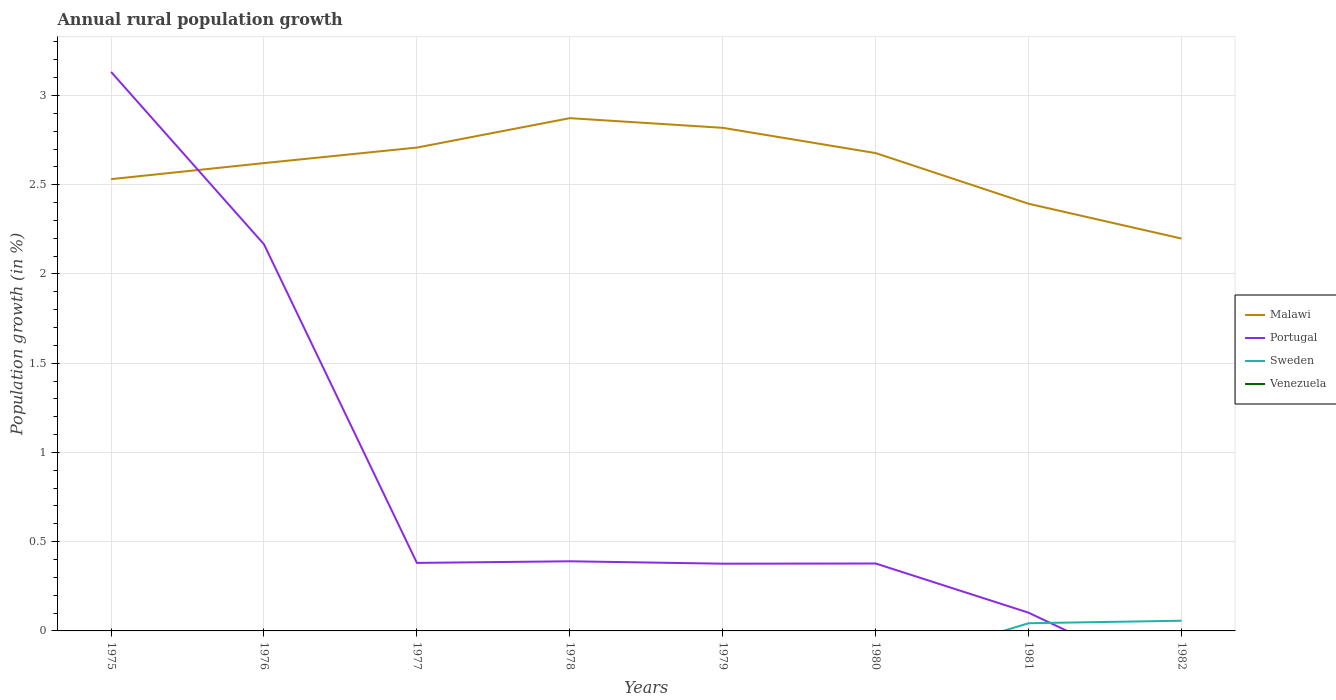Is the number of lines equal to the number of legend labels?
Your answer should be compact. No. Across all years, what is the maximum percentage of rural population growth in Malawi?
Provide a short and direct response. 2.2. What is the total percentage of rural population growth in Malawi in the graph?
Offer a very short reply. 0.42. What is the difference between the highest and the second highest percentage of rural population growth in Portugal?
Your answer should be very brief. 3.13. What is the difference between the highest and the lowest percentage of rural population growth in Malawi?
Make the answer very short. 5. What is the difference between two consecutive major ticks on the Y-axis?
Your answer should be very brief. 0.5. Does the graph contain any zero values?
Offer a terse response. Yes. Does the graph contain grids?
Keep it short and to the point. Yes. Where does the legend appear in the graph?
Provide a succinct answer. Center right. How many legend labels are there?
Your answer should be very brief. 4. How are the legend labels stacked?
Your answer should be very brief. Vertical. What is the title of the graph?
Ensure brevity in your answer.  Annual rural population growth. Does "Uzbekistan" appear as one of the legend labels in the graph?
Make the answer very short. No. What is the label or title of the X-axis?
Keep it short and to the point. Years. What is the label or title of the Y-axis?
Ensure brevity in your answer.  Population growth (in %). What is the Population growth (in %) of Malawi in 1975?
Your response must be concise. 2.53. What is the Population growth (in %) in Portugal in 1975?
Give a very brief answer. 3.13. What is the Population growth (in %) of Sweden in 1975?
Make the answer very short. 0. What is the Population growth (in %) in Venezuela in 1975?
Provide a short and direct response. 0. What is the Population growth (in %) of Malawi in 1976?
Your answer should be very brief. 2.62. What is the Population growth (in %) of Portugal in 1976?
Your response must be concise. 2.17. What is the Population growth (in %) in Malawi in 1977?
Ensure brevity in your answer.  2.71. What is the Population growth (in %) of Portugal in 1977?
Offer a very short reply. 0.38. What is the Population growth (in %) in Venezuela in 1977?
Offer a terse response. 0. What is the Population growth (in %) of Malawi in 1978?
Offer a very short reply. 2.87. What is the Population growth (in %) of Portugal in 1978?
Provide a short and direct response. 0.39. What is the Population growth (in %) of Sweden in 1978?
Offer a terse response. 0. What is the Population growth (in %) in Malawi in 1979?
Ensure brevity in your answer.  2.82. What is the Population growth (in %) in Portugal in 1979?
Give a very brief answer. 0.38. What is the Population growth (in %) in Venezuela in 1979?
Your response must be concise. 0. What is the Population growth (in %) of Malawi in 1980?
Keep it short and to the point. 2.68. What is the Population growth (in %) in Portugal in 1980?
Your answer should be very brief. 0.38. What is the Population growth (in %) of Sweden in 1980?
Give a very brief answer. 0. What is the Population growth (in %) in Malawi in 1981?
Your answer should be very brief. 2.39. What is the Population growth (in %) in Portugal in 1981?
Keep it short and to the point. 0.1. What is the Population growth (in %) of Sweden in 1981?
Your answer should be compact. 0.04. What is the Population growth (in %) of Malawi in 1982?
Give a very brief answer. 2.2. What is the Population growth (in %) in Sweden in 1982?
Make the answer very short. 0.06. What is the Population growth (in %) in Venezuela in 1982?
Make the answer very short. 0. Across all years, what is the maximum Population growth (in %) in Malawi?
Offer a terse response. 2.87. Across all years, what is the maximum Population growth (in %) of Portugal?
Make the answer very short. 3.13. Across all years, what is the maximum Population growth (in %) of Sweden?
Give a very brief answer. 0.06. Across all years, what is the minimum Population growth (in %) of Malawi?
Keep it short and to the point. 2.2. Across all years, what is the minimum Population growth (in %) of Sweden?
Provide a succinct answer. 0. What is the total Population growth (in %) in Malawi in the graph?
Your answer should be compact. 20.82. What is the total Population growth (in %) of Portugal in the graph?
Your response must be concise. 6.93. What is the total Population growth (in %) of Sweden in the graph?
Offer a terse response. 0.1. What is the total Population growth (in %) of Venezuela in the graph?
Provide a short and direct response. 0. What is the difference between the Population growth (in %) in Malawi in 1975 and that in 1976?
Offer a terse response. -0.09. What is the difference between the Population growth (in %) in Portugal in 1975 and that in 1976?
Your answer should be very brief. 0.97. What is the difference between the Population growth (in %) of Malawi in 1975 and that in 1977?
Give a very brief answer. -0.18. What is the difference between the Population growth (in %) in Portugal in 1975 and that in 1977?
Give a very brief answer. 2.75. What is the difference between the Population growth (in %) in Malawi in 1975 and that in 1978?
Your response must be concise. -0.34. What is the difference between the Population growth (in %) of Portugal in 1975 and that in 1978?
Offer a terse response. 2.74. What is the difference between the Population growth (in %) of Malawi in 1975 and that in 1979?
Your answer should be compact. -0.29. What is the difference between the Population growth (in %) of Portugal in 1975 and that in 1979?
Keep it short and to the point. 2.76. What is the difference between the Population growth (in %) in Malawi in 1975 and that in 1980?
Provide a short and direct response. -0.15. What is the difference between the Population growth (in %) of Portugal in 1975 and that in 1980?
Offer a terse response. 2.75. What is the difference between the Population growth (in %) of Malawi in 1975 and that in 1981?
Give a very brief answer. 0.14. What is the difference between the Population growth (in %) of Portugal in 1975 and that in 1981?
Offer a very short reply. 3.03. What is the difference between the Population growth (in %) in Malawi in 1975 and that in 1982?
Give a very brief answer. 0.33. What is the difference between the Population growth (in %) in Malawi in 1976 and that in 1977?
Your answer should be compact. -0.09. What is the difference between the Population growth (in %) of Portugal in 1976 and that in 1977?
Offer a terse response. 1.79. What is the difference between the Population growth (in %) in Malawi in 1976 and that in 1978?
Give a very brief answer. -0.25. What is the difference between the Population growth (in %) in Portugal in 1976 and that in 1978?
Give a very brief answer. 1.78. What is the difference between the Population growth (in %) in Malawi in 1976 and that in 1979?
Provide a succinct answer. -0.2. What is the difference between the Population growth (in %) in Portugal in 1976 and that in 1979?
Your response must be concise. 1.79. What is the difference between the Population growth (in %) in Malawi in 1976 and that in 1980?
Give a very brief answer. -0.06. What is the difference between the Population growth (in %) in Portugal in 1976 and that in 1980?
Make the answer very short. 1.79. What is the difference between the Population growth (in %) of Malawi in 1976 and that in 1981?
Keep it short and to the point. 0.23. What is the difference between the Population growth (in %) in Portugal in 1976 and that in 1981?
Your answer should be very brief. 2.06. What is the difference between the Population growth (in %) in Malawi in 1976 and that in 1982?
Keep it short and to the point. 0.42. What is the difference between the Population growth (in %) in Malawi in 1977 and that in 1978?
Make the answer very short. -0.16. What is the difference between the Population growth (in %) in Portugal in 1977 and that in 1978?
Your answer should be compact. -0.01. What is the difference between the Population growth (in %) of Malawi in 1977 and that in 1979?
Offer a terse response. -0.11. What is the difference between the Population growth (in %) of Portugal in 1977 and that in 1979?
Give a very brief answer. 0. What is the difference between the Population growth (in %) of Malawi in 1977 and that in 1980?
Ensure brevity in your answer.  0.03. What is the difference between the Population growth (in %) in Portugal in 1977 and that in 1980?
Your response must be concise. 0. What is the difference between the Population growth (in %) in Malawi in 1977 and that in 1981?
Offer a terse response. 0.31. What is the difference between the Population growth (in %) in Portugal in 1977 and that in 1981?
Your answer should be very brief. 0.28. What is the difference between the Population growth (in %) of Malawi in 1977 and that in 1982?
Your response must be concise. 0.51. What is the difference between the Population growth (in %) in Malawi in 1978 and that in 1979?
Your answer should be very brief. 0.05. What is the difference between the Population growth (in %) of Portugal in 1978 and that in 1979?
Provide a short and direct response. 0.01. What is the difference between the Population growth (in %) of Malawi in 1978 and that in 1980?
Keep it short and to the point. 0.2. What is the difference between the Population growth (in %) of Portugal in 1978 and that in 1980?
Provide a short and direct response. 0.01. What is the difference between the Population growth (in %) of Malawi in 1978 and that in 1981?
Give a very brief answer. 0.48. What is the difference between the Population growth (in %) of Portugal in 1978 and that in 1981?
Your answer should be very brief. 0.29. What is the difference between the Population growth (in %) in Malawi in 1978 and that in 1982?
Provide a short and direct response. 0.67. What is the difference between the Population growth (in %) of Malawi in 1979 and that in 1980?
Give a very brief answer. 0.14. What is the difference between the Population growth (in %) of Portugal in 1979 and that in 1980?
Make the answer very short. -0. What is the difference between the Population growth (in %) of Malawi in 1979 and that in 1981?
Ensure brevity in your answer.  0.43. What is the difference between the Population growth (in %) of Portugal in 1979 and that in 1981?
Provide a short and direct response. 0.27. What is the difference between the Population growth (in %) in Malawi in 1979 and that in 1982?
Ensure brevity in your answer.  0.62. What is the difference between the Population growth (in %) in Malawi in 1980 and that in 1981?
Your answer should be compact. 0.28. What is the difference between the Population growth (in %) of Portugal in 1980 and that in 1981?
Your answer should be compact. 0.28. What is the difference between the Population growth (in %) of Malawi in 1980 and that in 1982?
Make the answer very short. 0.48. What is the difference between the Population growth (in %) of Malawi in 1981 and that in 1982?
Ensure brevity in your answer.  0.2. What is the difference between the Population growth (in %) in Sweden in 1981 and that in 1982?
Provide a succinct answer. -0.01. What is the difference between the Population growth (in %) in Malawi in 1975 and the Population growth (in %) in Portugal in 1976?
Offer a very short reply. 0.37. What is the difference between the Population growth (in %) in Malawi in 1975 and the Population growth (in %) in Portugal in 1977?
Keep it short and to the point. 2.15. What is the difference between the Population growth (in %) of Malawi in 1975 and the Population growth (in %) of Portugal in 1978?
Make the answer very short. 2.14. What is the difference between the Population growth (in %) of Malawi in 1975 and the Population growth (in %) of Portugal in 1979?
Make the answer very short. 2.15. What is the difference between the Population growth (in %) in Malawi in 1975 and the Population growth (in %) in Portugal in 1980?
Make the answer very short. 2.15. What is the difference between the Population growth (in %) of Malawi in 1975 and the Population growth (in %) of Portugal in 1981?
Provide a short and direct response. 2.43. What is the difference between the Population growth (in %) of Malawi in 1975 and the Population growth (in %) of Sweden in 1981?
Make the answer very short. 2.49. What is the difference between the Population growth (in %) in Portugal in 1975 and the Population growth (in %) in Sweden in 1981?
Keep it short and to the point. 3.09. What is the difference between the Population growth (in %) in Malawi in 1975 and the Population growth (in %) in Sweden in 1982?
Provide a succinct answer. 2.47. What is the difference between the Population growth (in %) in Portugal in 1975 and the Population growth (in %) in Sweden in 1982?
Your response must be concise. 3.08. What is the difference between the Population growth (in %) of Malawi in 1976 and the Population growth (in %) of Portugal in 1977?
Offer a terse response. 2.24. What is the difference between the Population growth (in %) in Malawi in 1976 and the Population growth (in %) in Portugal in 1978?
Give a very brief answer. 2.23. What is the difference between the Population growth (in %) in Malawi in 1976 and the Population growth (in %) in Portugal in 1979?
Provide a succinct answer. 2.24. What is the difference between the Population growth (in %) of Malawi in 1976 and the Population growth (in %) of Portugal in 1980?
Provide a short and direct response. 2.24. What is the difference between the Population growth (in %) in Malawi in 1976 and the Population growth (in %) in Portugal in 1981?
Provide a short and direct response. 2.52. What is the difference between the Population growth (in %) in Malawi in 1976 and the Population growth (in %) in Sweden in 1981?
Make the answer very short. 2.58. What is the difference between the Population growth (in %) of Portugal in 1976 and the Population growth (in %) of Sweden in 1981?
Make the answer very short. 2.12. What is the difference between the Population growth (in %) in Malawi in 1976 and the Population growth (in %) in Sweden in 1982?
Provide a succinct answer. 2.56. What is the difference between the Population growth (in %) in Portugal in 1976 and the Population growth (in %) in Sweden in 1982?
Offer a terse response. 2.11. What is the difference between the Population growth (in %) of Malawi in 1977 and the Population growth (in %) of Portugal in 1978?
Offer a very short reply. 2.32. What is the difference between the Population growth (in %) in Malawi in 1977 and the Population growth (in %) in Portugal in 1979?
Ensure brevity in your answer.  2.33. What is the difference between the Population growth (in %) of Malawi in 1977 and the Population growth (in %) of Portugal in 1980?
Your answer should be very brief. 2.33. What is the difference between the Population growth (in %) in Malawi in 1977 and the Population growth (in %) in Portugal in 1981?
Offer a terse response. 2.61. What is the difference between the Population growth (in %) of Malawi in 1977 and the Population growth (in %) of Sweden in 1981?
Make the answer very short. 2.67. What is the difference between the Population growth (in %) of Portugal in 1977 and the Population growth (in %) of Sweden in 1981?
Make the answer very short. 0.34. What is the difference between the Population growth (in %) in Malawi in 1977 and the Population growth (in %) in Sweden in 1982?
Provide a succinct answer. 2.65. What is the difference between the Population growth (in %) in Portugal in 1977 and the Population growth (in %) in Sweden in 1982?
Keep it short and to the point. 0.32. What is the difference between the Population growth (in %) in Malawi in 1978 and the Population growth (in %) in Portugal in 1979?
Keep it short and to the point. 2.5. What is the difference between the Population growth (in %) in Malawi in 1978 and the Population growth (in %) in Portugal in 1980?
Provide a short and direct response. 2.5. What is the difference between the Population growth (in %) in Malawi in 1978 and the Population growth (in %) in Portugal in 1981?
Your answer should be very brief. 2.77. What is the difference between the Population growth (in %) of Malawi in 1978 and the Population growth (in %) of Sweden in 1981?
Offer a terse response. 2.83. What is the difference between the Population growth (in %) in Portugal in 1978 and the Population growth (in %) in Sweden in 1981?
Provide a succinct answer. 0.35. What is the difference between the Population growth (in %) in Malawi in 1978 and the Population growth (in %) in Sweden in 1982?
Your response must be concise. 2.82. What is the difference between the Population growth (in %) in Portugal in 1978 and the Population growth (in %) in Sweden in 1982?
Make the answer very short. 0.33. What is the difference between the Population growth (in %) of Malawi in 1979 and the Population growth (in %) of Portugal in 1980?
Offer a very short reply. 2.44. What is the difference between the Population growth (in %) in Malawi in 1979 and the Population growth (in %) in Portugal in 1981?
Offer a terse response. 2.72. What is the difference between the Population growth (in %) of Malawi in 1979 and the Population growth (in %) of Sweden in 1981?
Provide a short and direct response. 2.78. What is the difference between the Population growth (in %) in Portugal in 1979 and the Population growth (in %) in Sweden in 1981?
Give a very brief answer. 0.33. What is the difference between the Population growth (in %) of Malawi in 1979 and the Population growth (in %) of Sweden in 1982?
Your answer should be compact. 2.76. What is the difference between the Population growth (in %) of Portugal in 1979 and the Population growth (in %) of Sweden in 1982?
Ensure brevity in your answer.  0.32. What is the difference between the Population growth (in %) in Malawi in 1980 and the Population growth (in %) in Portugal in 1981?
Make the answer very short. 2.58. What is the difference between the Population growth (in %) in Malawi in 1980 and the Population growth (in %) in Sweden in 1981?
Your answer should be very brief. 2.63. What is the difference between the Population growth (in %) of Portugal in 1980 and the Population growth (in %) of Sweden in 1981?
Make the answer very short. 0.33. What is the difference between the Population growth (in %) of Malawi in 1980 and the Population growth (in %) of Sweden in 1982?
Ensure brevity in your answer.  2.62. What is the difference between the Population growth (in %) of Portugal in 1980 and the Population growth (in %) of Sweden in 1982?
Keep it short and to the point. 0.32. What is the difference between the Population growth (in %) in Malawi in 1981 and the Population growth (in %) in Sweden in 1982?
Give a very brief answer. 2.34. What is the difference between the Population growth (in %) in Portugal in 1981 and the Population growth (in %) in Sweden in 1982?
Your answer should be compact. 0.04. What is the average Population growth (in %) in Malawi per year?
Provide a short and direct response. 2.6. What is the average Population growth (in %) of Portugal per year?
Ensure brevity in your answer.  0.87. What is the average Population growth (in %) in Sweden per year?
Keep it short and to the point. 0.01. What is the average Population growth (in %) of Venezuela per year?
Your answer should be compact. 0. In the year 1975, what is the difference between the Population growth (in %) of Malawi and Population growth (in %) of Portugal?
Provide a short and direct response. -0.6. In the year 1976, what is the difference between the Population growth (in %) of Malawi and Population growth (in %) of Portugal?
Ensure brevity in your answer.  0.46. In the year 1977, what is the difference between the Population growth (in %) of Malawi and Population growth (in %) of Portugal?
Offer a very short reply. 2.33. In the year 1978, what is the difference between the Population growth (in %) in Malawi and Population growth (in %) in Portugal?
Ensure brevity in your answer.  2.48. In the year 1979, what is the difference between the Population growth (in %) of Malawi and Population growth (in %) of Portugal?
Your answer should be very brief. 2.44. In the year 1980, what is the difference between the Population growth (in %) of Malawi and Population growth (in %) of Portugal?
Provide a succinct answer. 2.3. In the year 1981, what is the difference between the Population growth (in %) of Malawi and Population growth (in %) of Portugal?
Keep it short and to the point. 2.29. In the year 1981, what is the difference between the Population growth (in %) in Malawi and Population growth (in %) in Sweden?
Ensure brevity in your answer.  2.35. In the year 1981, what is the difference between the Population growth (in %) of Portugal and Population growth (in %) of Sweden?
Your response must be concise. 0.06. In the year 1982, what is the difference between the Population growth (in %) of Malawi and Population growth (in %) of Sweden?
Ensure brevity in your answer.  2.14. What is the ratio of the Population growth (in %) of Malawi in 1975 to that in 1976?
Provide a short and direct response. 0.97. What is the ratio of the Population growth (in %) of Portugal in 1975 to that in 1976?
Your answer should be very brief. 1.45. What is the ratio of the Population growth (in %) in Malawi in 1975 to that in 1977?
Your answer should be very brief. 0.93. What is the ratio of the Population growth (in %) in Portugal in 1975 to that in 1977?
Provide a short and direct response. 8.22. What is the ratio of the Population growth (in %) of Malawi in 1975 to that in 1978?
Give a very brief answer. 0.88. What is the ratio of the Population growth (in %) of Portugal in 1975 to that in 1978?
Offer a very short reply. 8.03. What is the ratio of the Population growth (in %) of Malawi in 1975 to that in 1979?
Ensure brevity in your answer.  0.9. What is the ratio of the Population growth (in %) of Portugal in 1975 to that in 1979?
Provide a succinct answer. 8.31. What is the ratio of the Population growth (in %) of Malawi in 1975 to that in 1980?
Provide a succinct answer. 0.95. What is the ratio of the Population growth (in %) of Portugal in 1975 to that in 1980?
Provide a succinct answer. 8.29. What is the ratio of the Population growth (in %) in Malawi in 1975 to that in 1981?
Your answer should be compact. 1.06. What is the ratio of the Population growth (in %) in Portugal in 1975 to that in 1981?
Make the answer very short. 30.67. What is the ratio of the Population growth (in %) of Malawi in 1975 to that in 1982?
Offer a very short reply. 1.15. What is the ratio of the Population growth (in %) in Malawi in 1976 to that in 1977?
Ensure brevity in your answer.  0.97. What is the ratio of the Population growth (in %) in Portugal in 1976 to that in 1977?
Provide a succinct answer. 5.68. What is the ratio of the Population growth (in %) of Malawi in 1976 to that in 1978?
Give a very brief answer. 0.91. What is the ratio of the Population growth (in %) of Portugal in 1976 to that in 1978?
Provide a short and direct response. 5.55. What is the ratio of the Population growth (in %) of Malawi in 1976 to that in 1979?
Offer a very short reply. 0.93. What is the ratio of the Population growth (in %) in Portugal in 1976 to that in 1979?
Provide a succinct answer. 5.75. What is the ratio of the Population growth (in %) in Malawi in 1976 to that in 1980?
Ensure brevity in your answer.  0.98. What is the ratio of the Population growth (in %) of Portugal in 1976 to that in 1980?
Your response must be concise. 5.73. What is the ratio of the Population growth (in %) of Malawi in 1976 to that in 1981?
Your answer should be compact. 1.1. What is the ratio of the Population growth (in %) in Portugal in 1976 to that in 1981?
Your answer should be very brief. 21.21. What is the ratio of the Population growth (in %) of Malawi in 1976 to that in 1982?
Your response must be concise. 1.19. What is the ratio of the Population growth (in %) in Malawi in 1977 to that in 1978?
Offer a terse response. 0.94. What is the ratio of the Population growth (in %) of Portugal in 1977 to that in 1978?
Give a very brief answer. 0.98. What is the ratio of the Population growth (in %) in Malawi in 1977 to that in 1979?
Offer a very short reply. 0.96. What is the ratio of the Population growth (in %) in Portugal in 1977 to that in 1979?
Keep it short and to the point. 1.01. What is the ratio of the Population growth (in %) of Malawi in 1977 to that in 1980?
Give a very brief answer. 1.01. What is the ratio of the Population growth (in %) of Portugal in 1977 to that in 1980?
Provide a succinct answer. 1.01. What is the ratio of the Population growth (in %) of Malawi in 1977 to that in 1981?
Offer a terse response. 1.13. What is the ratio of the Population growth (in %) of Portugal in 1977 to that in 1981?
Ensure brevity in your answer.  3.73. What is the ratio of the Population growth (in %) in Malawi in 1977 to that in 1982?
Make the answer very short. 1.23. What is the ratio of the Population growth (in %) in Malawi in 1978 to that in 1979?
Give a very brief answer. 1.02. What is the ratio of the Population growth (in %) in Portugal in 1978 to that in 1979?
Provide a short and direct response. 1.04. What is the ratio of the Population growth (in %) of Malawi in 1978 to that in 1980?
Keep it short and to the point. 1.07. What is the ratio of the Population growth (in %) of Portugal in 1978 to that in 1980?
Make the answer very short. 1.03. What is the ratio of the Population growth (in %) of Malawi in 1978 to that in 1981?
Provide a short and direct response. 1.2. What is the ratio of the Population growth (in %) of Portugal in 1978 to that in 1981?
Keep it short and to the point. 3.82. What is the ratio of the Population growth (in %) of Malawi in 1978 to that in 1982?
Provide a short and direct response. 1.31. What is the ratio of the Population growth (in %) of Malawi in 1979 to that in 1980?
Ensure brevity in your answer.  1.05. What is the ratio of the Population growth (in %) in Malawi in 1979 to that in 1981?
Give a very brief answer. 1.18. What is the ratio of the Population growth (in %) in Portugal in 1979 to that in 1981?
Your response must be concise. 3.69. What is the ratio of the Population growth (in %) in Malawi in 1979 to that in 1982?
Your answer should be compact. 1.28. What is the ratio of the Population growth (in %) of Malawi in 1980 to that in 1981?
Provide a succinct answer. 1.12. What is the ratio of the Population growth (in %) in Portugal in 1980 to that in 1981?
Your response must be concise. 3.7. What is the ratio of the Population growth (in %) of Malawi in 1980 to that in 1982?
Your answer should be compact. 1.22. What is the ratio of the Population growth (in %) in Malawi in 1981 to that in 1982?
Offer a terse response. 1.09. What is the ratio of the Population growth (in %) in Sweden in 1981 to that in 1982?
Provide a short and direct response. 0.75. What is the difference between the highest and the second highest Population growth (in %) of Malawi?
Provide a succinct answer. 0.05. What is the difference between the highest and the second highest Population growth (in %) of Portugal?
Offer a terse response. 0.97. What is the difference between the highest and the lowest Population growth (in %) of Malawi?
Provide a succinct answer. 0.67. What is the difference between the highest and the lowest Population growth (in %) in Portugal?
Make the answer very short. 3.13. What is the difference between the highest and the lowest Population growth (in %) in Sweden?
Make the answer very short. 0.06. 